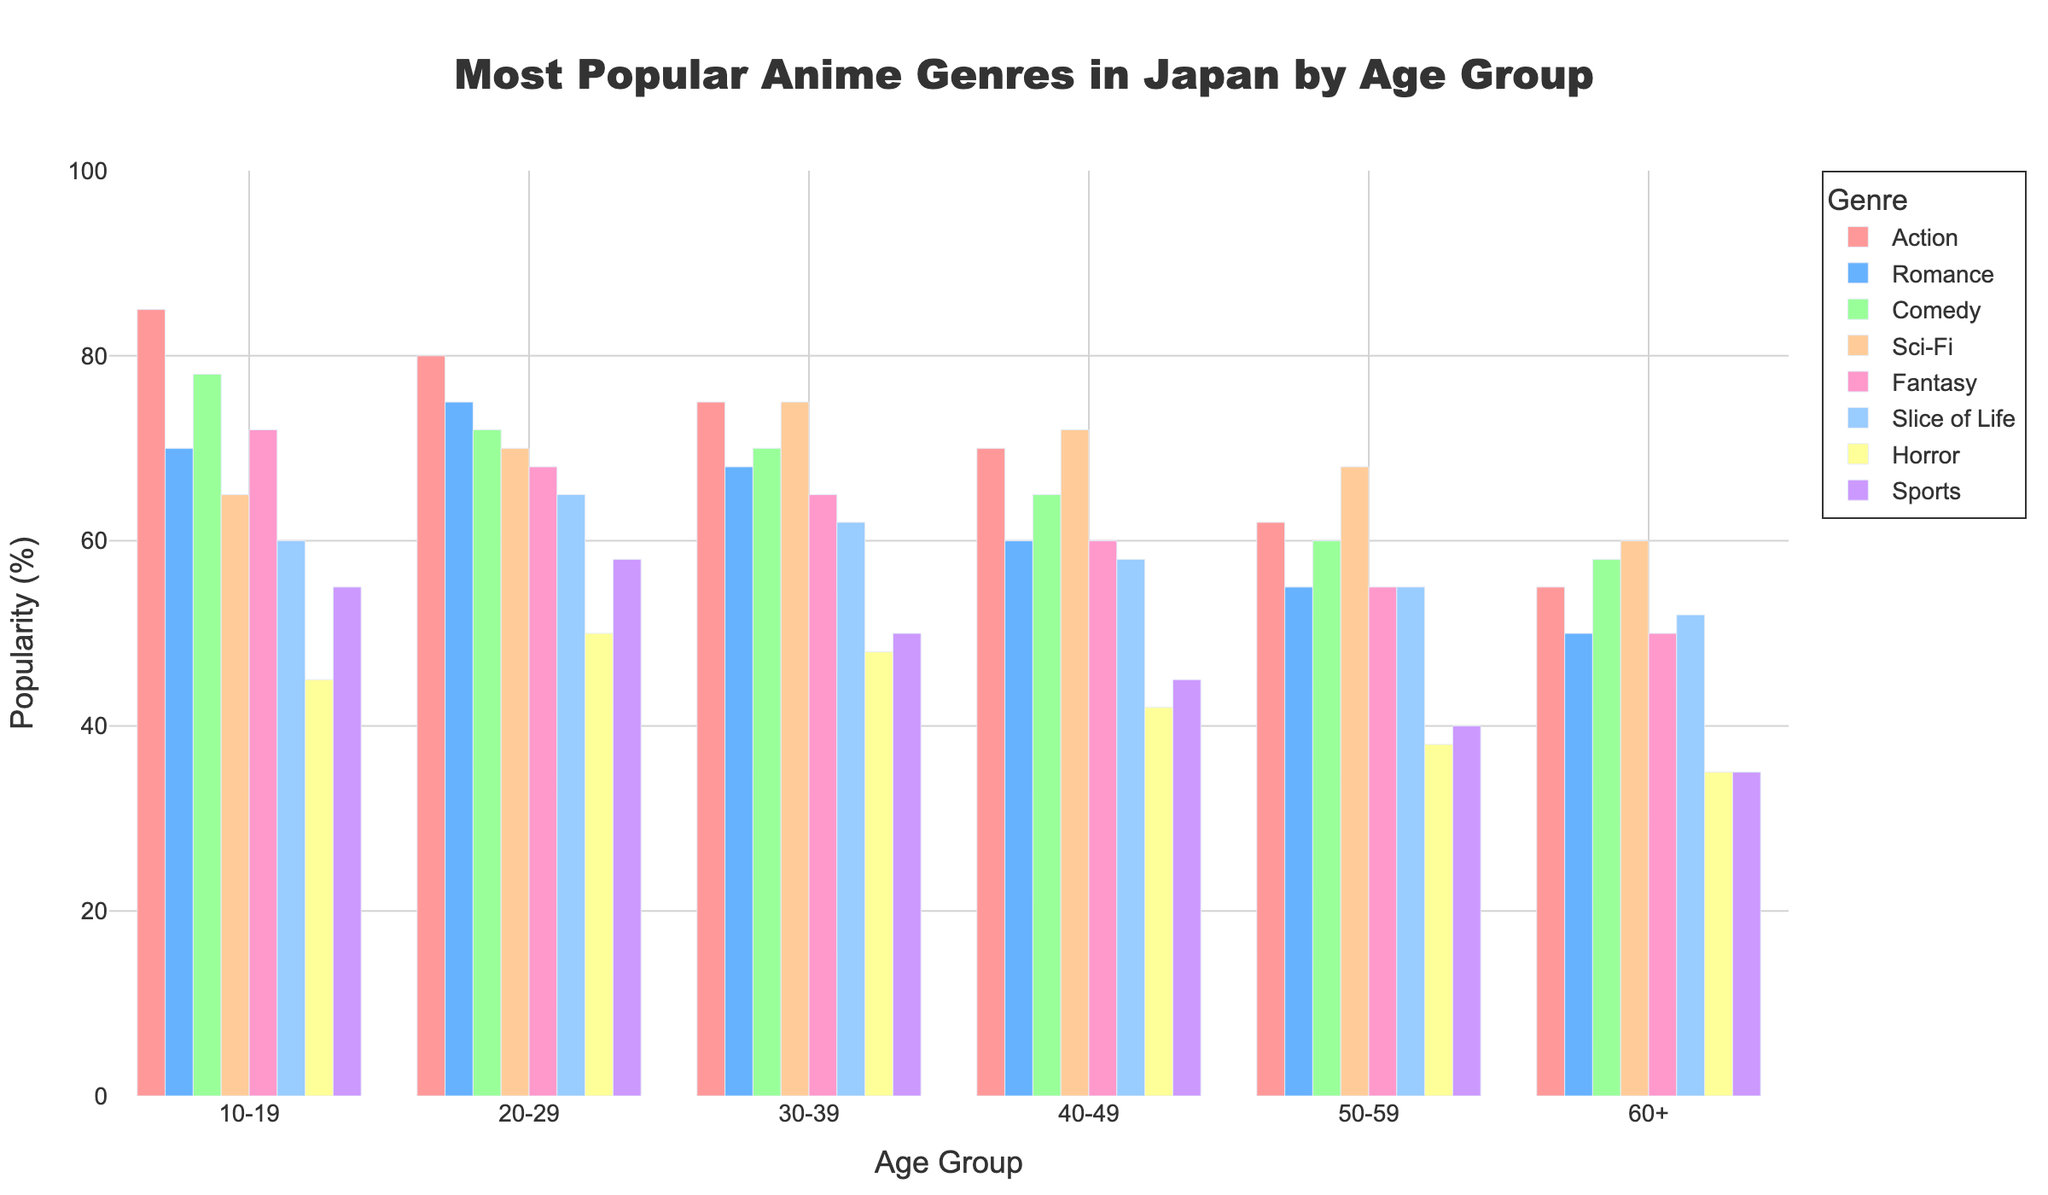Which age group enjoys Action genre the most? Look for the bar that represents the Action genre across all age groups and identify the tallest one. The Action genre is most enjoyed by the 10-19 age group with a popularity of 85%.
Answer: 10-19 Which genre is equally popular among the 30-39 and 40-49 age groups? Look for bars with the same height between the 30-39 and 40-49 age groups. The Sci-Fi genre has equal popularity of 75% among these age groups.
Answer: Sci-Fi How much more popular is Comedy compared to Horror in the 20-29 age group? Find the Comedy and Horror bars for the 20-29 age group. Comedy is at 72%, and Horror is at 50%. The difference is 72% - 50% = 22%.
Answer: 22% What is the average popularity of the Romance genre across all age groups? Sum the popularity values of the Romance genre across all age groups (70+75+68+60+55+50) and divide by the total number of age groups, 6. (70+75+68+60+55+50) / 6 = 63.
Answer: 63 Which genre is the least popular among the 60+ age group? Identify the shortest bar within the 60+ age group. The Horror genre is the least popular with a value of 35%.
Answer: Horror How does the popularity of the Fantasy genre change with increasing age groups? Examine the bars representing the Fantasy genre from the youngest age group to the oldest. Popularity decreases as follows: 72% (10-19), 68% (20-29), 65% (30-39), 60% (40-49), 55% (50-59), and 50% (60+).
Answer: It decreases What is the total popularity of Slice of Life for people under 30? Sum the popularity values of the Slice of Life genre for the 10-19 and 20-29 age groups. 60% (10-19) + 65% (20-29) = 125%.
Answer: 125% Are there any genres with the same popularity across three different age groups? Check for genres with the same popularity value in three age groups. The Fantasy genre shows consistency in its popularity across the ages of 10-19 (72%), 30-39 (65%), and 40-49 (60%), but no exact matches across three groups.
Answer: No Which genres show a decline in popularity as age increases from 10-19 to 60+? Compare the popularity values of each genre between the age groups 10-19 and 60+. All genres (Action, Romance, Comedy, Sci-Fi, Fantasy, Slice of Life, Horror, and Sports) show a decline.
Answer: All of them 